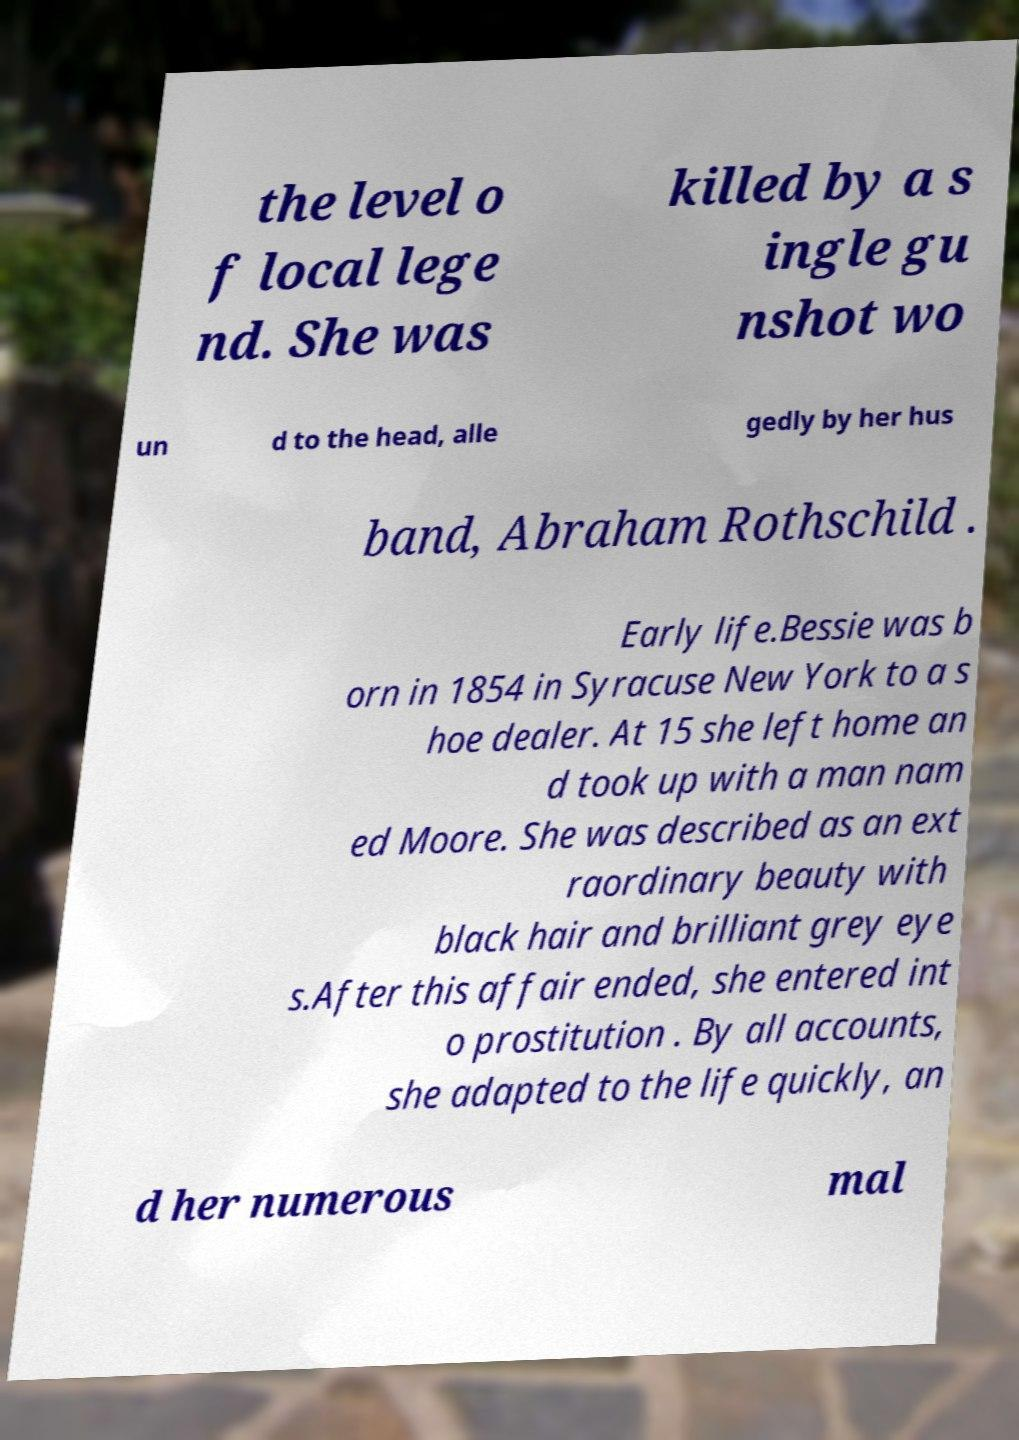Can you accurately transcribe the text from the provided image for me? the level o f local lege nd. She was killed by a s ingle gu nshot wo un d to the head, alle gedly by her hus band, Abraham Rothschild . Early life.Bessie was b orn in 1854 in Syracuse New York to a s hoe dealer. At 15 she left home an d took up with a man nam ed Moore. She was described as an ext raordinary beauty with black hair and brilliant grey eye s.After this affair ended, she entered int o prostitution . By all accounts, she adapted to the life quickly, an d her numerous mal 